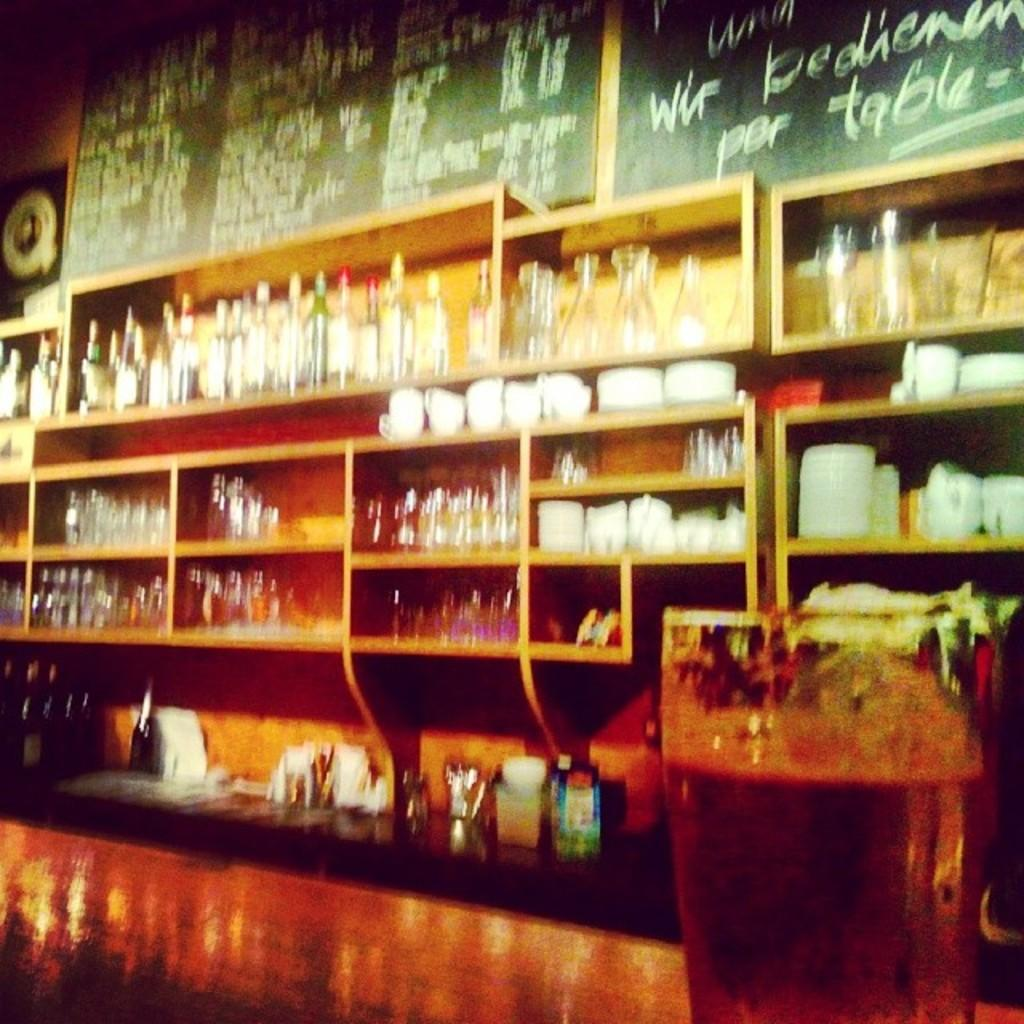<image>
Summarize the visual content of the image. A chalk sign written in German has the word Table written on it. 